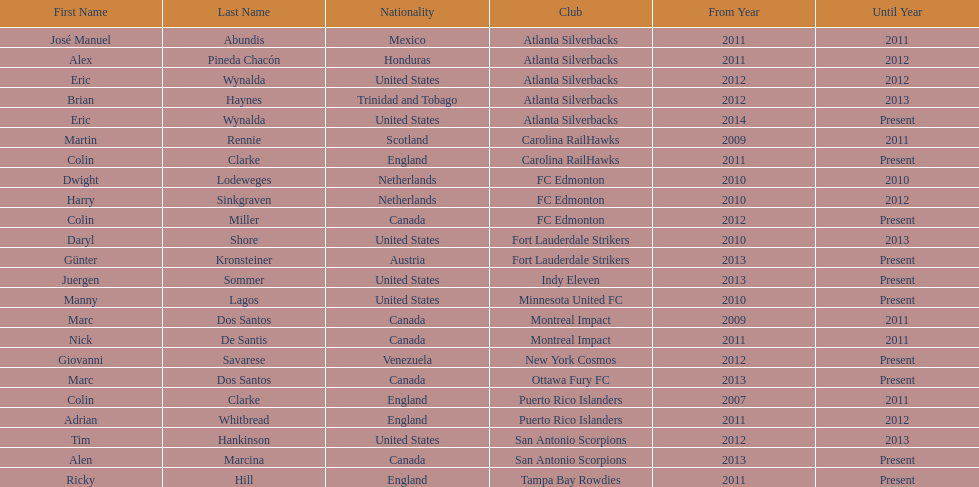How many coaches have coached from america? 6. 